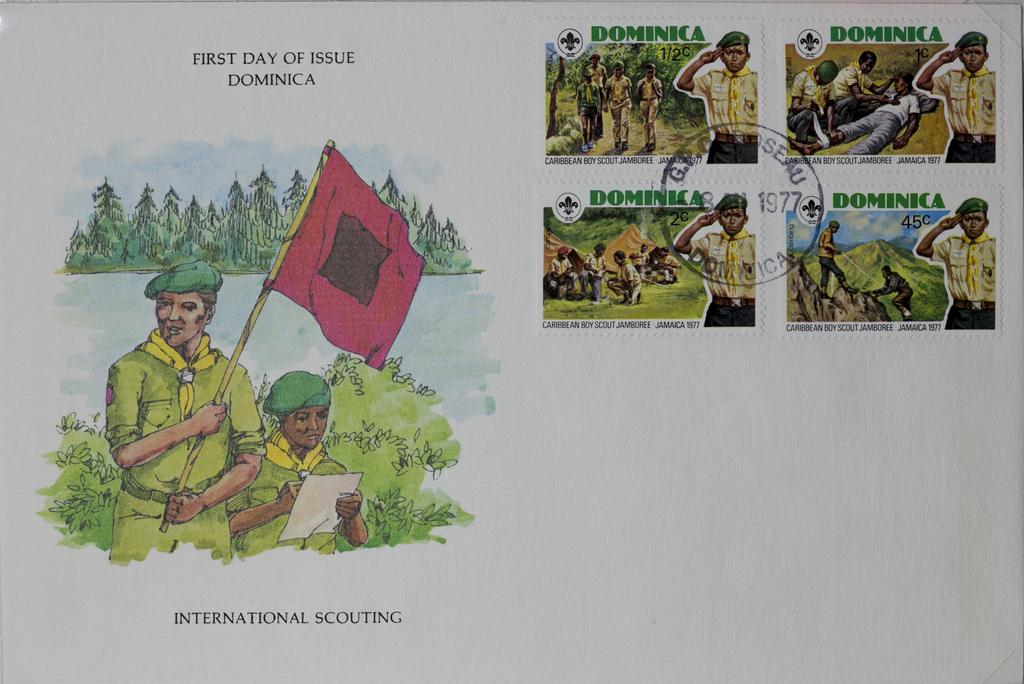Provide a one-sentence caption for the provided image. a book that has international scouting in it. 